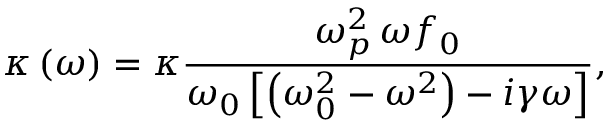<formula> <loc_0><loc_0><loc_500><loc_500>\kappa \left ( \omega \right ) = \kappa \frac { \omega _ { p } ^ { 2 } \, \omega f _ { 0 } } { \omega _ { 0 } \left [ \left ( \omega _ { 0 } ^ { 2 } - \omega ^ { 2 } \right ) - i \gamma \omega \right ] } ,</formula> 